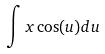<formula> <loc_0><loc_0><loc_500><loc_500>\int x \cos ( u ) d u</formula> 